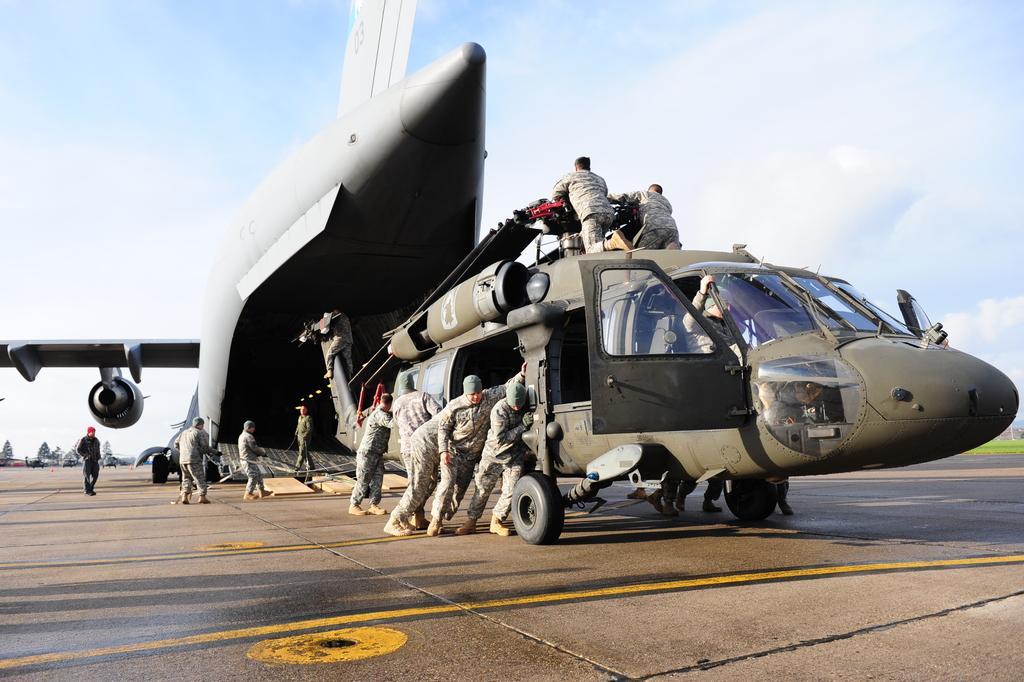In one or two sentences, can you explain what this image depicts? In this picture we can see an army hercules, chopper and people on the runway. Behind the army hercules, there are vehicles and the sky. 